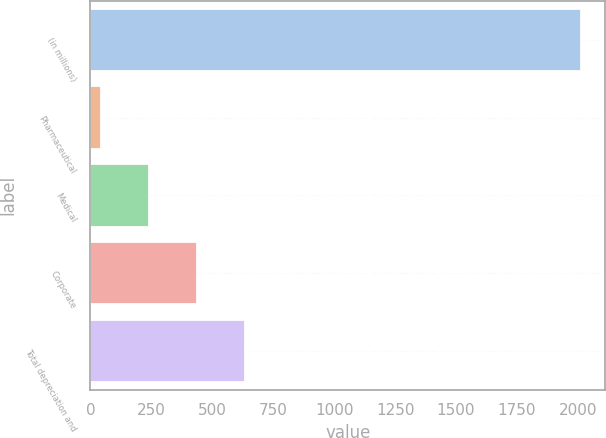<chart> <loc_0><loc_0><loc_500><loc_500><bar_chart><fcel>(in millions)<fcel>Pharmaceutical<fcel>Medical<fcel>Corporate<fcel>Total depreciation and<nl><fcel>2011<fcel>42<fcel>238.9<fcel>435.8<fcel>632.7<nl></chart> 